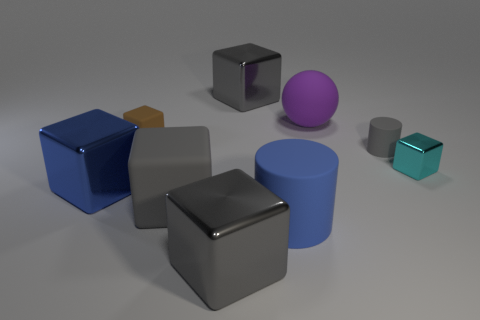How many objects are either gray metallic objects behind the gray rubber cylinder or small objects that are right of the large purple matte sphere?
Your answer should be compact. 3. How big is the cyan object that is on the right side of the large cube in front of the large cylinder?
Your response must be concise. Small. What size is the cyan metal thing?
Keep it short and to the point. Small. There is a large metal object that is behind the blue metallic object; is it the same color as the rubber object right of the big purple matte object?
Make the answer very short. Yes. How many other objects are the same material as the big blue cylinder?
Give a very brief answer. 4. Are any small green rubber balls visible?
Provide a succinct answer. No. Is the material of the tiny thing left of the tiny matte cylinder the same as the small cyan cube?
Offer a very short reply. No. What is the material of the big blue thing that is the same shape as the small metal object?
Your response must be concise. Metal. There is a big object that is the same color as the large cylinder; what material is it?
Your answer should be very brief. Metal. Are there fewer large gray shiny cubes than blue matte things?
Your response must be concise. No. 